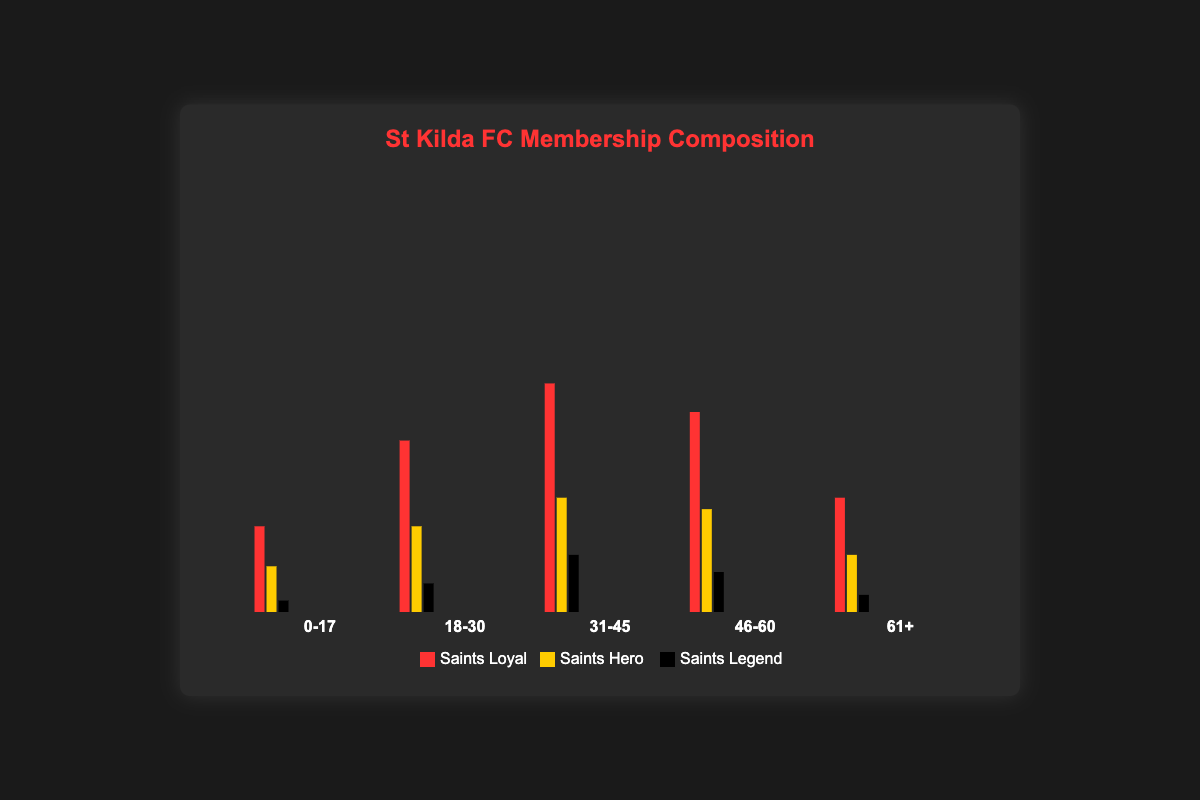What is the title of the Isotype Plot? The title is shown at the top center of the plot in bold and colored in red. It reads "St Kilda FC Membership Composition".
Answer: St Kilda FC Membership Composition Which age group has the most "Saints Loyal" members? By examining the bars colored in red for the "Saints Loyal" tier across all age groups, it is clear that the age group "31-45" has the tallest bar, indicating the highest number of members.
Answer: 31-45 How many members are in the "Saints Hero" tier within the "18-30" age group? Look at the yellow bar (representing "Saints Hero") in the "18-30" age group. The bar height corresponds to the value listed directly in the data or near the bar.
Answer: 1500 What is the total number of members in the "61+" age group across all membership tiers? Add the number of members in each tier for the "61+" age group: 2000 (“Saints Loyal”) + 1000 (“Saints Hero”) + 300 (“Saints Legend”). This calculation yields 3300.
Answer: 3300 Which membership tier is least popular among the "0-17" age group? By comparing the heights of the bars for all three membership tiers within the "0-17" age group, the black bar (representing "Saints Legend") is the shortest, indicating it has the fewest members.
Answer: Saints Legend Is the "Saints Hero" membership in the "46-60" age group greater than the "Saints Hero" membership in the "31-45" age group? Compare the heights of the yellow bars (representing "Saints Hero") for both age groups. For “46-60”, it’s 1800; for “31-45”, it’s 2000. Since 1800 is less than 2000, the answer is no.
Answer: No What is the total number of "Saints Legend" members from all age groups combined? Add the number of "Saints Legend" members across all age groups: 200 (“0-17”) + 500 (“18-30”) + 1000 (“31-45”) + 700 (“46-60”) + 300 (“61+”). This gives a total of 2700.
Answer: 2700 Which age group has the most evenly distributed membership tiers? By visually inspecting the bars for each age group, the "0-17" age group has bars that are relatively closer in height, indicating a more even distribution across "Saints Loyal", "Saints Hero", and "Saints Legend".
Answer: 0-17 